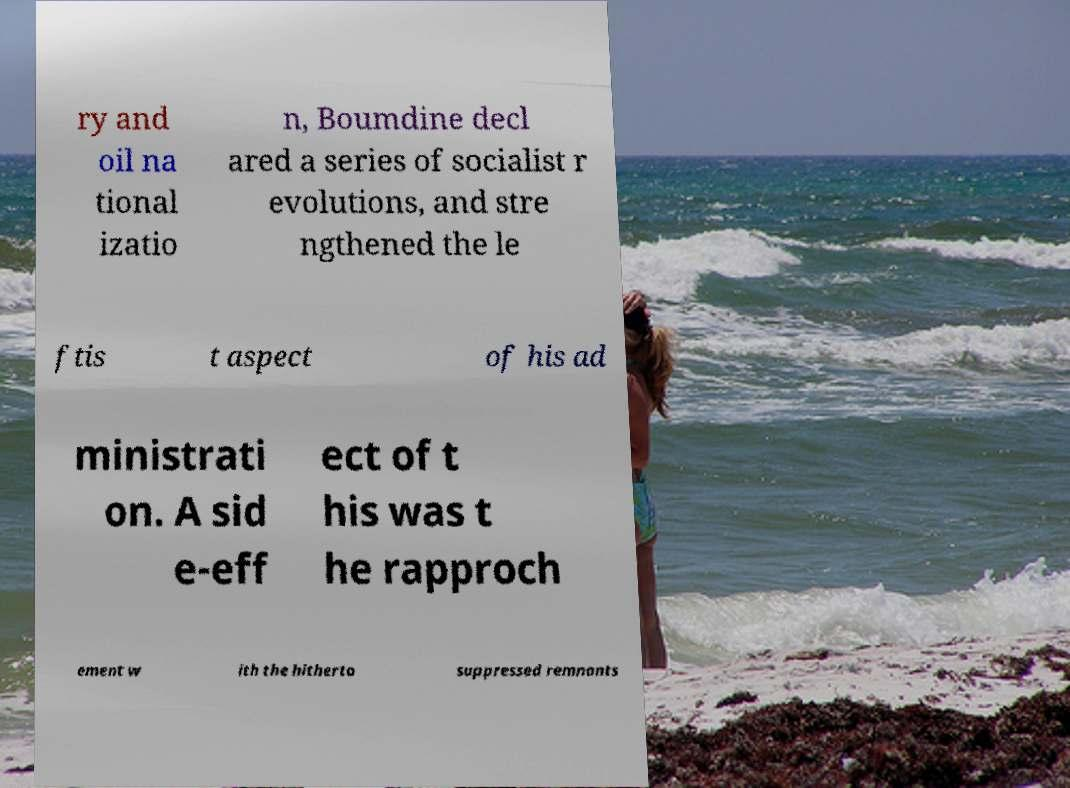Please read and relay the text visible in this image. What does it say? ry and oil na tional izatio n, Boumdine decl ared a series of socialist r evolutions, and stre ngthened the le ftis t aspect of his ad ministrati on. A sid e-eff ect of t his was t he rapproch ement w ith the hitherto suppressed remnants 